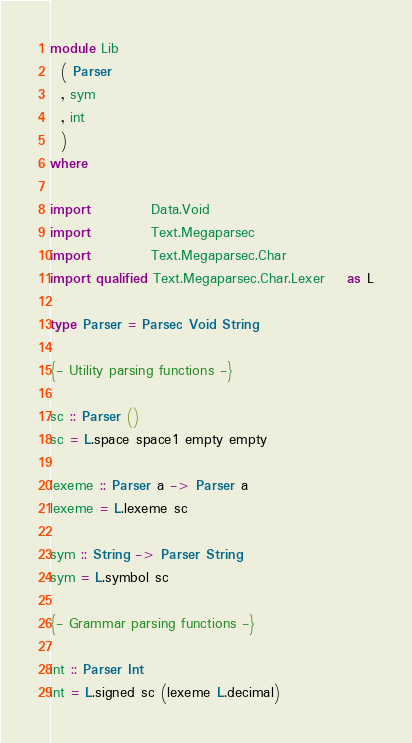Convert code to text. <code><loc_0><loc_0><loc_500><loc_500><_Haskell_>module Lib
  ( Parser
  , sym
  , int
  )
where

import           Data.Void
import           Text.Megaparsec
import           Text.Megaparsec.Char
import qualified Text.Megaparsec.Char.Lexer    as L

type Parser = Parsec Void String

{- Utility parsing functions -}

sc :: Parser ()
sc = L.space space1 empty empty

lexeme :: Parser a -> Parser a
lexeme = L.lexeme sc

sym :: String -> Parser String
sym = L.symbol sc

{- Grammar parsing functions -}

int :: Parser Int
int = L.signed sc (lexeme L.decimal)
</code> 